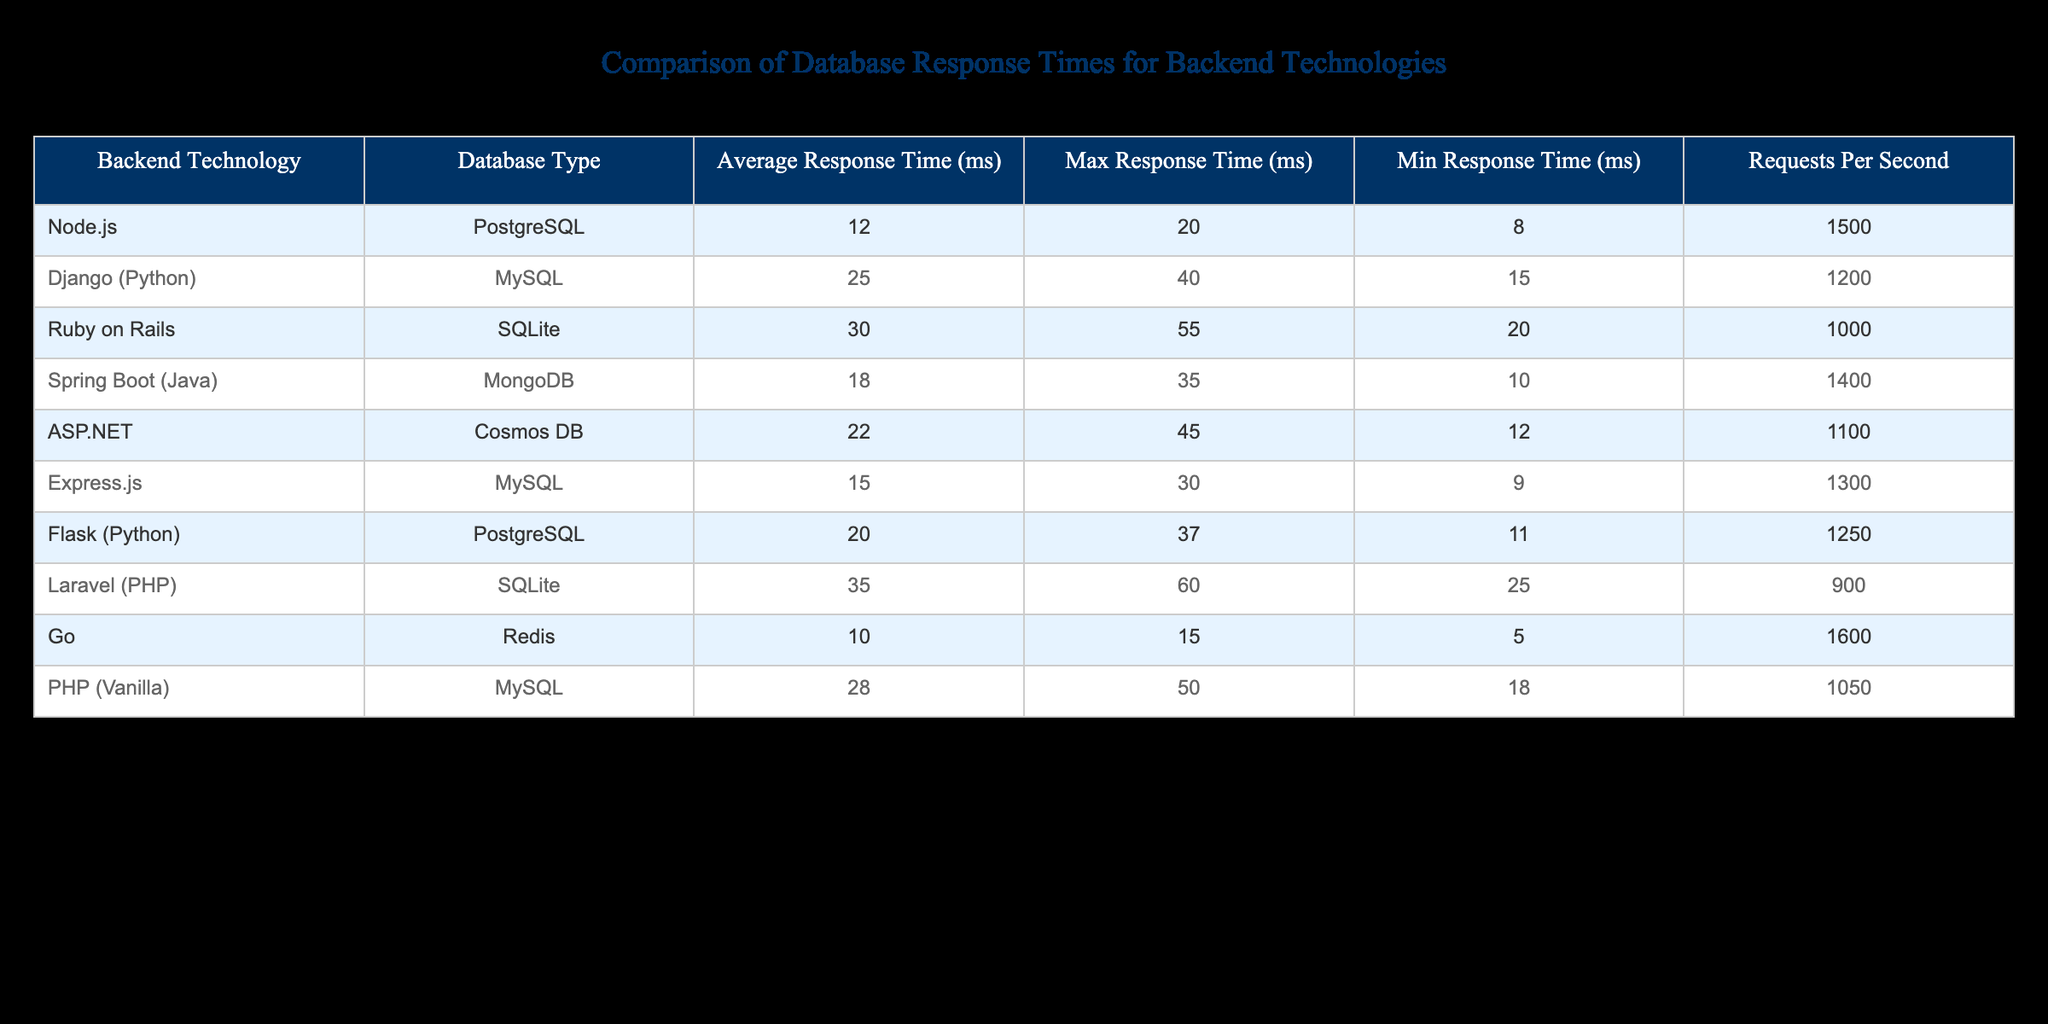What is the average response time for Node.js using PostgreSQL? The average response time for Node.js with PostgreSQL is given directly in the table as 12 ms.
Answer: 12 ms Which backend technology has the highest maximum response time? By examining the "Max Response Time (ms)" column, we see that Laravel (PHP) has the highest maximum response time at 60 ms.
Answer: Laravel (PHP) What is the difference in average response time between Django (Python) and Express.js? The average response time for Django (Python) is 25 ms, and for Express.js, it is 15 ms. The difference is 25 ms - 15 ms = 10 ms.
Answer: 10 ms Is the average response time for Go with Redis better than Node.js with PostgreSQL? The average response time for Go (Redis) is 10 ms, which is lower than that for Node.js (PostgreSQL) at 12 ms. Therefore, yes, Go has a better average response time.
Answer: Yes Which backend technology has the highest number of requests per second? By comparing the "Requests Per Second" column, we find that Go with Redis has the highest value at 1600 requests per second.
Answer: Go (Redis) What is the average response time for technologies using SQLite? There are two technologies using SQLite: Ruby on Rails with 30 ms and Laravel with 35 ms. The average response time is (30 + 35) / 2 = 32.5 ms.
Answer: 32.5 ms Is the minimum response time for ASP.NET with Cosmos DB less than 15 ms? The minimum response time for ASP.NET with Cosmos DB is 12 ms, which is indeed less than 15 ms.
Answer: Yes Which technology has a lower maximum response time, Spring Boot (Java) or Django (Python)? Spring Boot has a maximum response time of 35 ms while Django has a maximum of 40 ms. Since 35 ms is lower than 40 ms, Spring Boot has a lower maximum response time.
Answer: Spring Boot (Java) If we consider all backend technologies, what is the average of the minimum response times? The minimum response times are 8 (Node.js) + 15 (Django) + 20 (Ruby on Rails) + 10 (Spring Boot) + 12 (ASP.NET) + 9 (Express.js) + 11 (Flask) + 25 (Laravel) + 5 (Go) + 18 (PHP) totaling 138. There are 10 technologies, thus the average is 138 / 10 = 13.8 ms.
Answer: 13.8 ms 